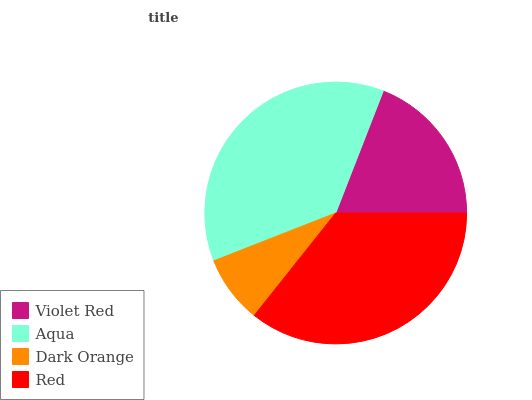Is Dark Orange the minimum?
Answer yes or no. Yes. Is Aqua the maximum?
Answer yes or no. Yes. Is Aqua the minimum?
Answer yes or no. No. Is Dark Orange the maximum?
Answer yes or no. No. Is Aqua greater than Dark Orange?
Answer yes or no. Yes. Is Dark Orange less than Aqua?
Answer yes or no. Yes. Is Dark Orange greater than Aqua?
Answer yes or no. No. Is Aqua less than Dark Orange?
Answer yes or no. No. Is Red the high median?
Answer yes or no. Yes. Is Violet Red the low median?
Answer yes or no. Yes. Is Dark Orange the high median?
Answer yes or no. No. Is Aqua the low median?
Answer yes or no. No. 